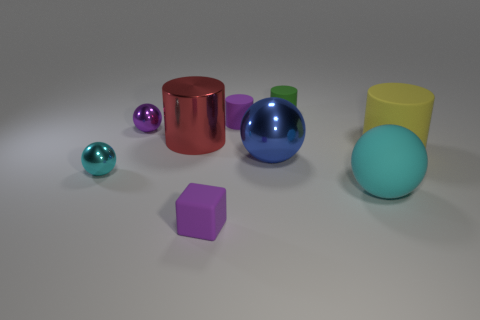What is the material of the cylinder that is the same color as the rubber cube?
Keep it short and to the point. Rubber. Are there any large metal objects of the same color as the block?
Your answer should be very brief. No. Is the size of the green object the same as the cyan rubber ball?
Provide a short and direct response. No. Do the big matte cylinder and the cube have the same color?
Provide a succinct answer. No. There is a cyan thing behind the cyan thing right of the blue metallic thing; what is its material?
Ensure brevity in your answer.  Metal. There is another cyan thing that is the same shape as the big cyan thing; what material is it?
Provide a short and direct response. Metal. There is a cyan object on the right side of the purple rubber cylinder; is it the same size as the purple sphere?
Ensure brevity in your answer.  No. What number of metal things are either big cyan spheres or large blue objects?
Offer a terse response. 1. There is a large object that is both behind the cyan metal object and to the right of the tiny green thing; what is it made of?
Ensure brevity in your answer.  Rubber. Do the large yellow cylinder and the red cylinder have the same material?
Provide a succinct answer. No. 